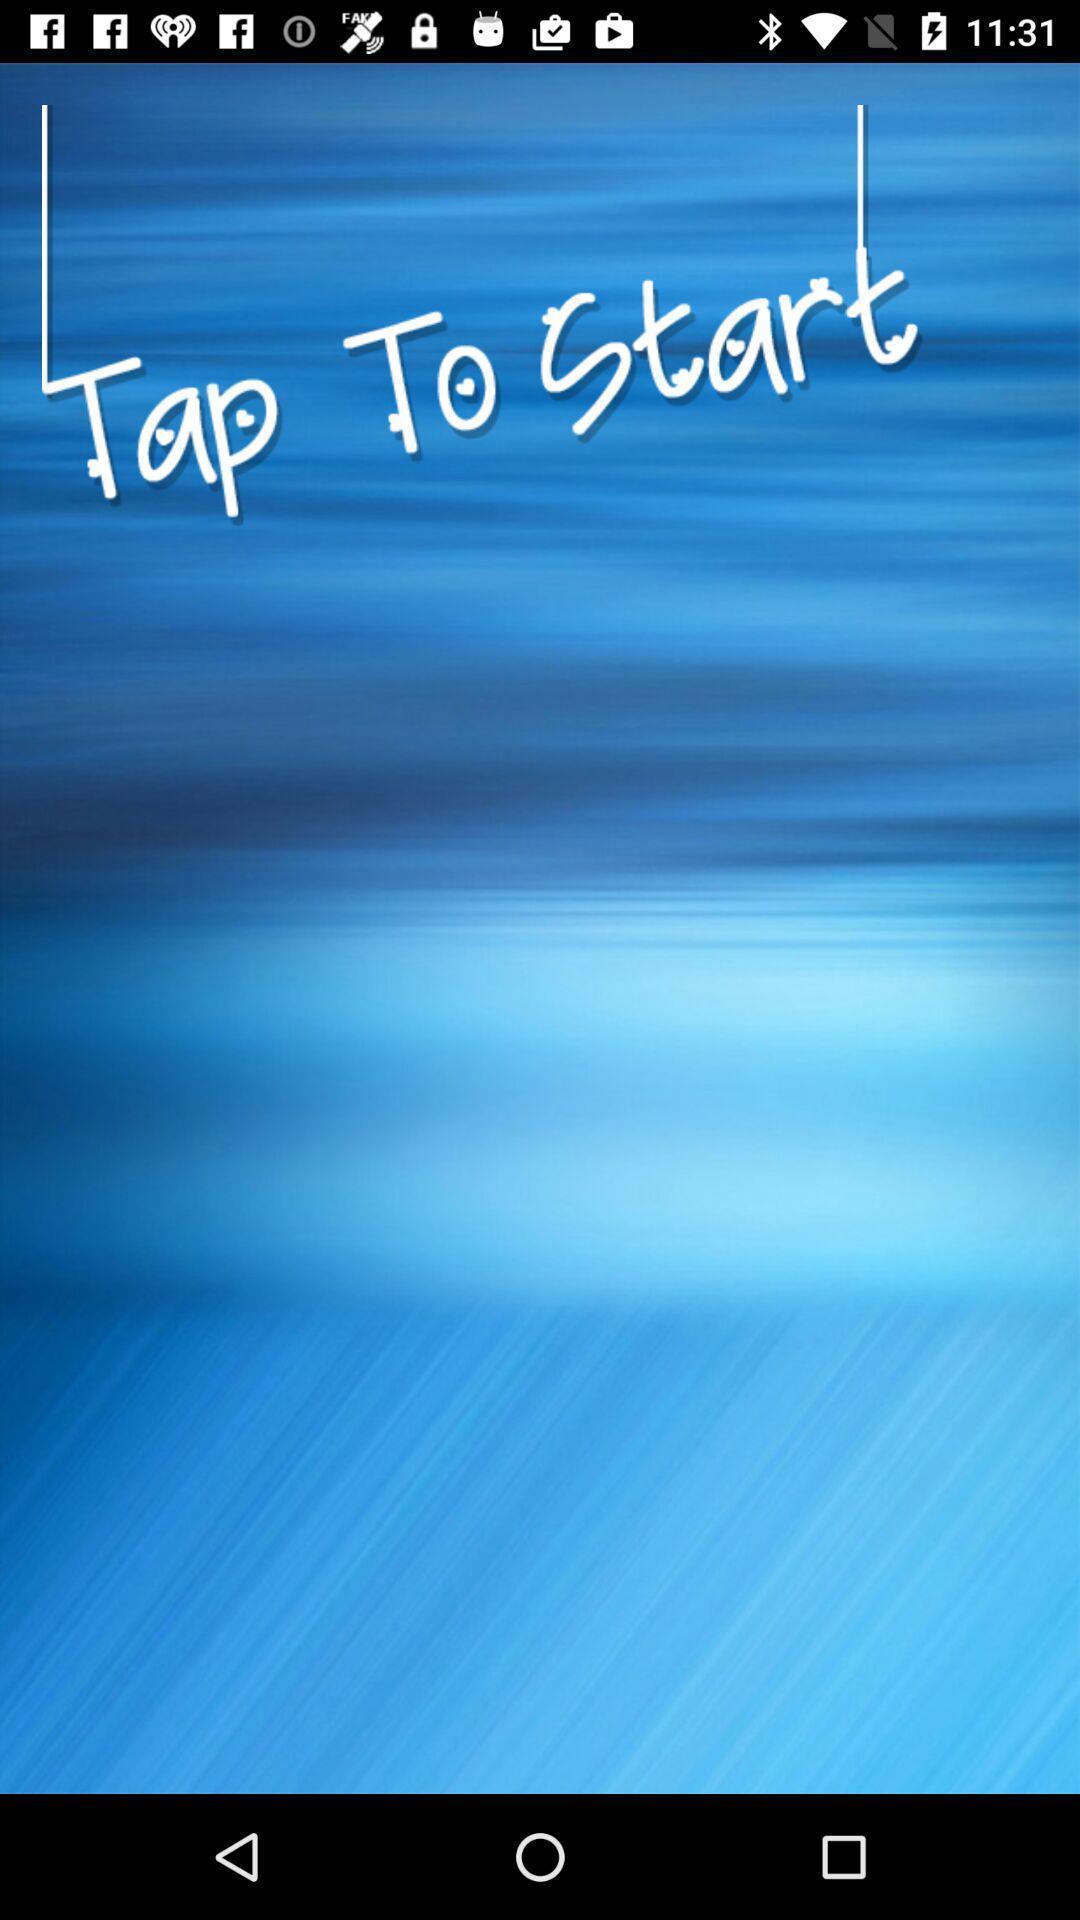Provide a description of this screenshot. Start page. 